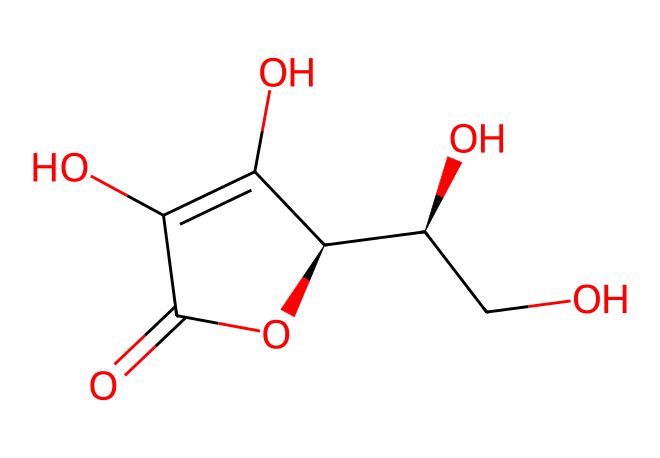What is the name of this chemical? The SMILES representation corresponds to ascorbic acid, commonly known as vitamin C. This is identified through the structure that includes multiple hydroxyl groups and a lactone ring.
Answer: ascorbic acid How many carbon atoms are present in this structure? The structure shows a total of 6 carbon atoms, visible in the skeletal formula representation. Each carbon is typically linked to functional groups or other carbon atoms.
Answer: six What is the chemical formula of this compound? The formula can be determined by counting the number of each type of atom in the structure: there are 6 carbon atoms, 8 hydrogen atoms, and 6 oxygen atoms, leading to the formula C6H8O6.
Answer: C6H8O6 What is the functional group that suggests this is an antioxidant? The presence of multiple hydroxyl (–OH) groups indicates that this compound has antioxidant properties because these groups can donate electrons and neutralize free radicals.
Answer: hydroxyl group What type of molecule is this? The structure reveals that this compound is a vitamin due to its classification, specifically as an antioxidant vitamin. Molecules like ascorbic acid play a vital role in protecting cells from oxidative stress.
Answer: vitamin Does this compound contain any double bonds? Yes, the structure contains double bonds, which can be identified in the lactone ring and the presence of the carbonyl group. This inform the reactivity and stability of the molecule.
Answer: yes How many hydroxyl groups are present in this chemical? The structure contains four hydroxyl groups, visible from the branching and functional groups indicated in the SMILES representation, which significantly contribute to its solubility and reactivity.
Answer: four 